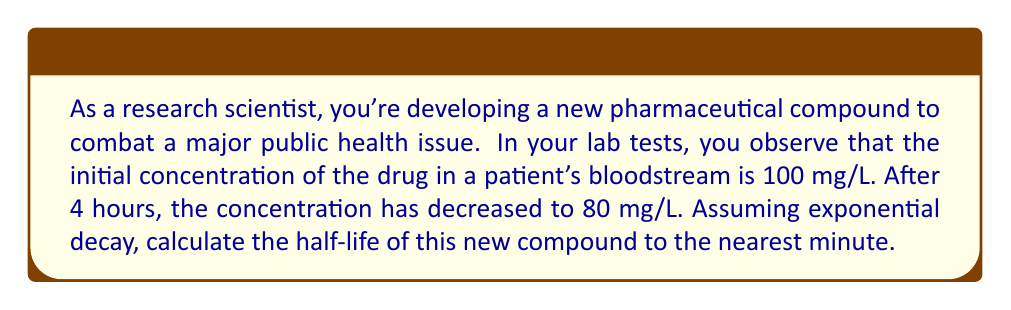Give your solution to this math problem. Let's approach this step-by-step using the exponential decay function:

1) The general form of exponential decay is:
   $$C(t) = C_0 e^{-kt}$$
   where $C(t)$ is the concentration at time $t$, $C_0$ is the initial concentration, and $k$ is the decay constant.

2) We know:
   $C_0 = 100$ mg/L
   $C(4) = 80$ mg/L
   $t = 4$ hours

3) Substituting into the equation:
   $$80 = 100 e^{-4k}$$

4) Solving for $k$:
   $$\frac{80}{100} = e^{-4k}$$
   $$0.8 = e^{-4k}$$
   $$\ln(0.8) = -4k$$
   $$k = -\frac{\ln(0.8)}{4} \approx 0.0558$$

5) The half-life $t_{1/2}$ is the time it takes for the concentration to reach half its initial value. It's related to $k$ by:
   $$t_{1/2} = \frac{\ln(2)}{k}$$

6) Substituting our value for $k$:
   $$t_{1/2} = \frac{\ln(2)}{0.0558} \approx 12.42$$ hours

7) Converting to minutes:
   $$12.42 \times 60 \approx 745.2$$ minutes

8) Rounding to the nearest minute:
   745 minutes
Answer: 745 minutes 